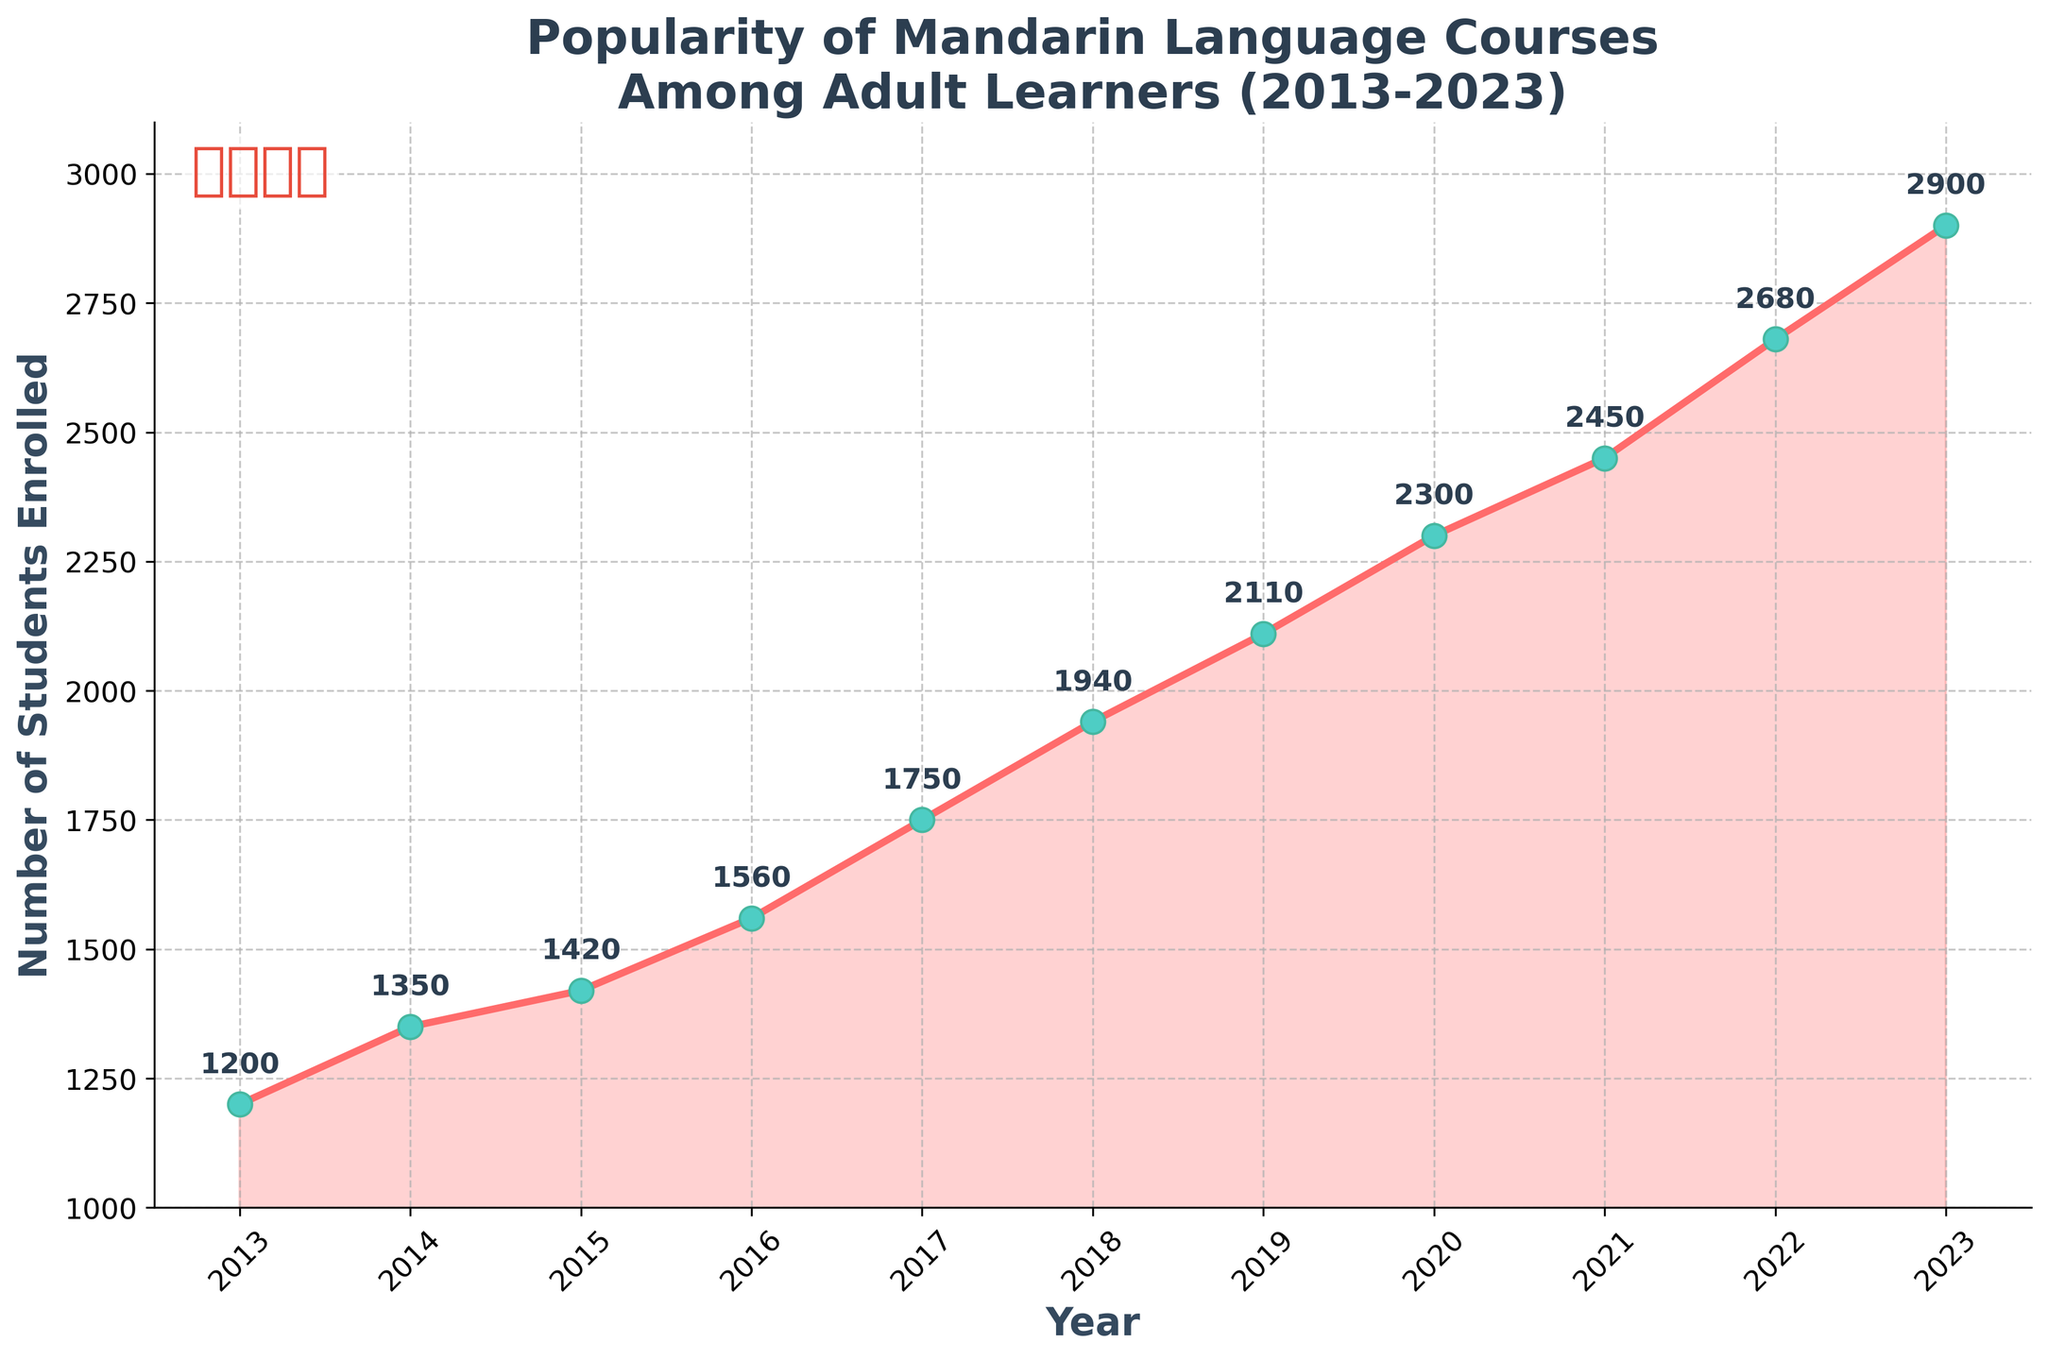When was the highest number of students enrolled in Mandarin language courses? To answer this question, look at the data points in the plot. The highest enrollment is at the peak of the line graph. The year at this peak point is 2023.
Answer: 2023 What is the title of the plot? The title is usually displayed at the top of the plot. Upon observation, the title of the plot is "Popularity of Mandarin Language Courses Among Adult Learners (2013-2023)."
Answer: Popularity of Mandarin Language Courses Among Adult Learners (2013-2023) How many students were enrolled in 2015? Locate the data point for the year 2015. The corresponding value on the y-axis indicates the number of students enrolled, which is 1420.
Answer: 1420 What is the total increase in the number of students enrolled from 2013 to 2023? To find the increase, subtract the number of students in 2013 from the number in 2023. This is 2900 (2023) - 1200 (2013) = 1700.
Answer: 1700 Which year saw the highest increase in student enrollment compared to the previous year? Compute the year-on-year differences and find the maximum. The largest increase is between 2022 (2680) and 2023 (2900), which is an increase of 220 students.
Answer: 2023 How many years saw an increase of more than 150 students compared to the previous year? Calculate the year-on-year increases and count how many exceed 150. These years are 2016, 2017, 2018, 2019, 2020, 2022, and 2023 (7 years).
Answer: 7 By how much did the number of students enrolled increase from 2019 to 2020? The number of students enrolled in 2019 is 2110 and in 2020 is 2300. The increase is 2300 - 2110 = 190.
Answer: 190 What is the average number of students enrolled from 2013 to 2023? Sum the number of students enrolled for all years and divide by the number of years (11). The sum is 21360 (1200 + 1350 + 1420 + 1560 + 1750 + 1940 + 2110 + 2300 + 2450 + 2680 + 2900), so the average is 21360 / 11 = 1941.
Answer: 1941 